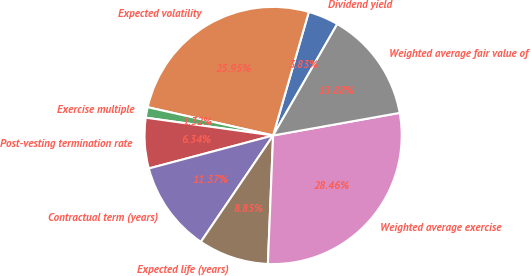<chart> <loc_0><loc_0><loc_500><loc_500><pie_chart><fcel>Dividend yield<fcel>Expected volatility<fcel>Exercise multiple<fcel>Post-vesting termination rate<fcel>Contractual term (years)<fcel>Expected life (years)<fcel>Weighted average exercise<fcel>Weighted average fair value of<nl><fcel>3.83%<fcel>25.95%<fcel>1.32%<fcel>6.34%<fcel>11.37%<fcel>8.85%<fcel>28.46%<fcel>13.88%<nl></chart> 